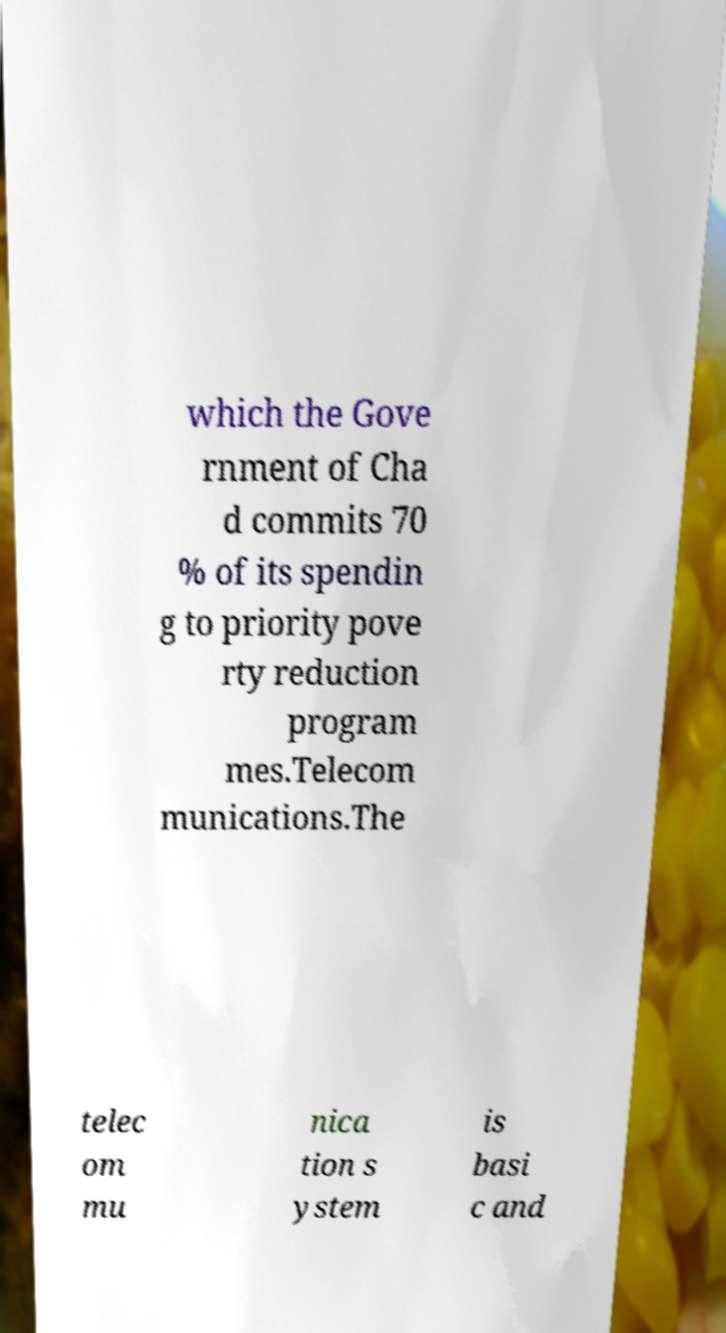What messages or text are displayed in this image? I need them in a readable, typed format. which the Gove rnment of Cha d commits 70 % of its spendin g to priority pove rty reduction program mes.Telecom munications.The telec om mu nica tion s ystem is basi c and 